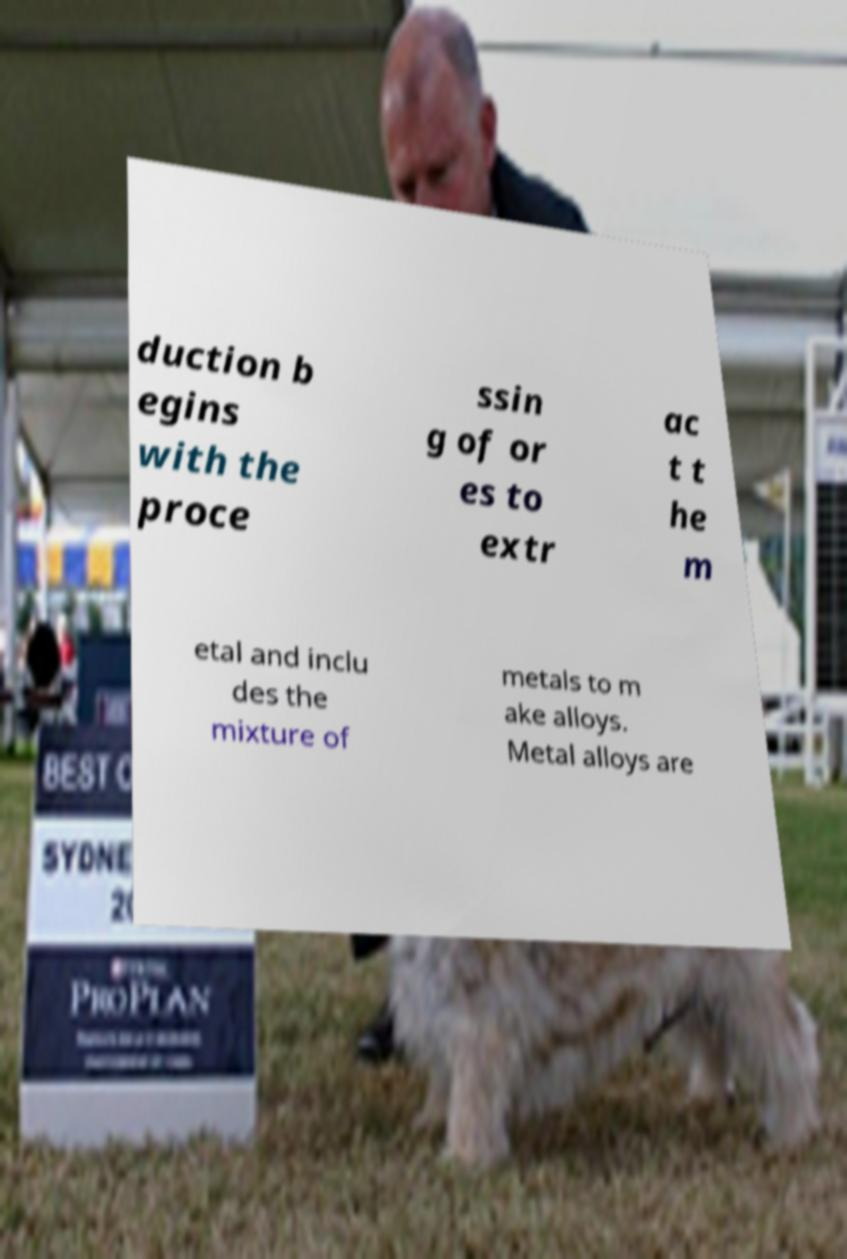Could you assist in decoding the text presented in this image and type it out clearly? duction b egins with the proce ssin g of or es to extr ac t t he m etal and inclu des the mixture of metals to m ake alloys. Metal alloys are 